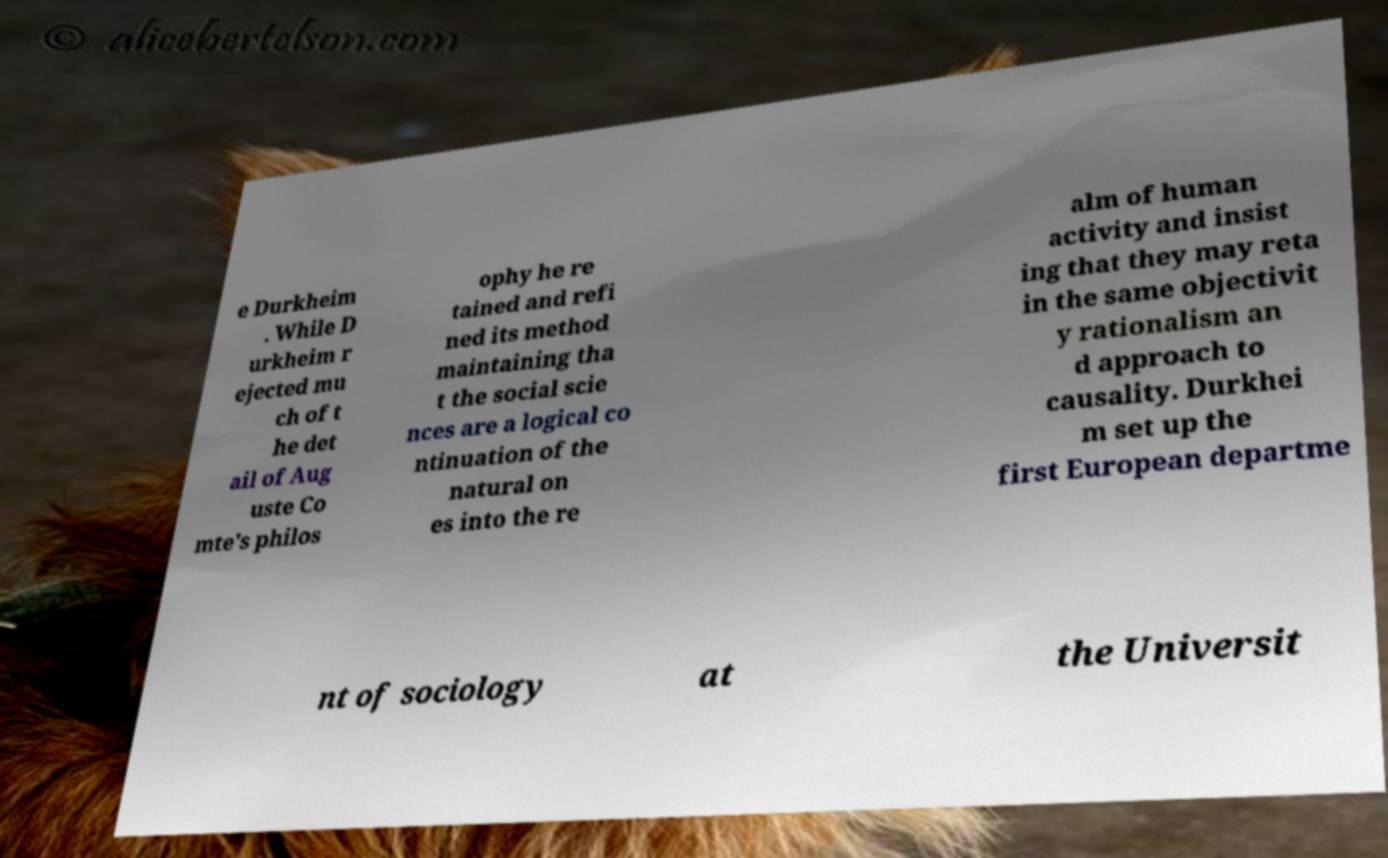Please identify and transcribe the text found in this image. e Durkheim . While D urkheim r ejected mu ch of t he det ail of Aug uste Co mte's philos ophy he re tained and refi ned its method maintaining tha t the social scie nces are a logical co ntinuation of the natural on es into the re alm of human activity and insist ing that they may reta in the same objectivit y rationalism an d approach to causality. Durkhei m set up the first European departme nt of sociology at the Universit 